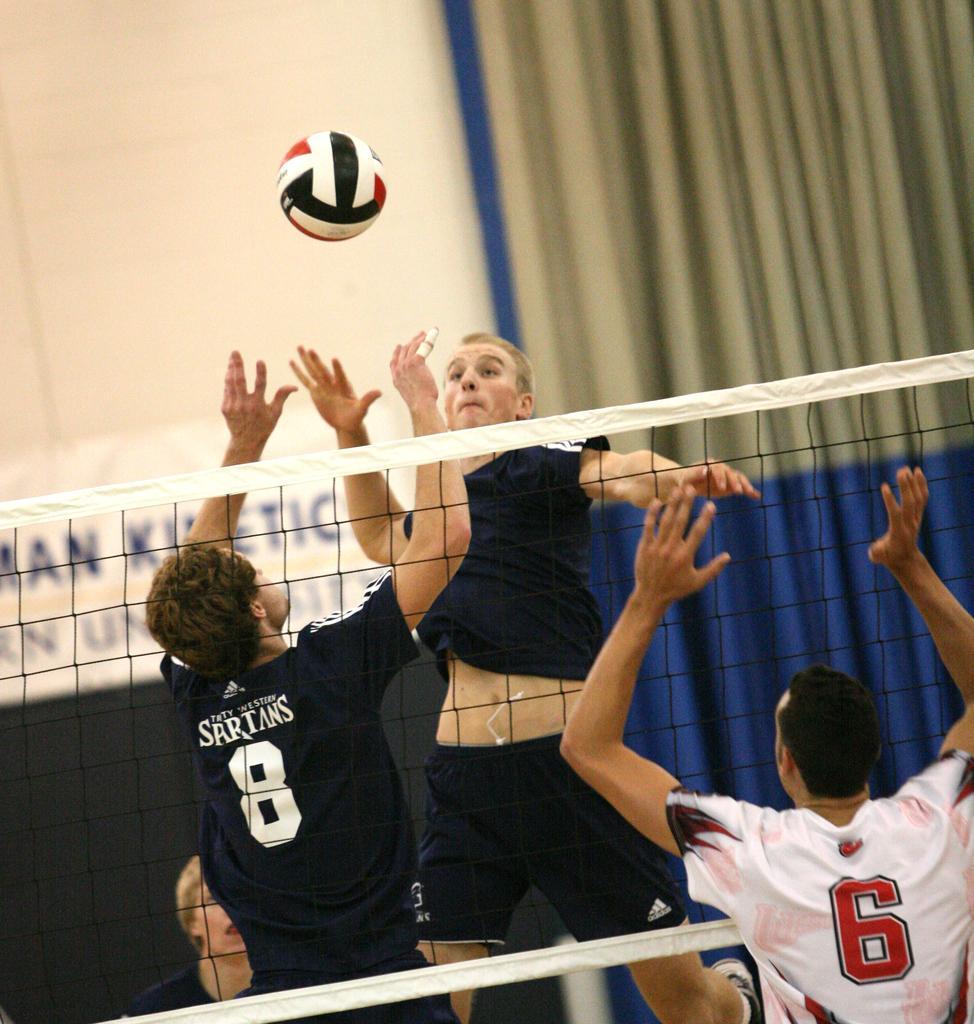Describe this image in one or two sentences. In this picture we can see the persons who are playing throw ball. This is the mesh. And on the background there is a curtain. 